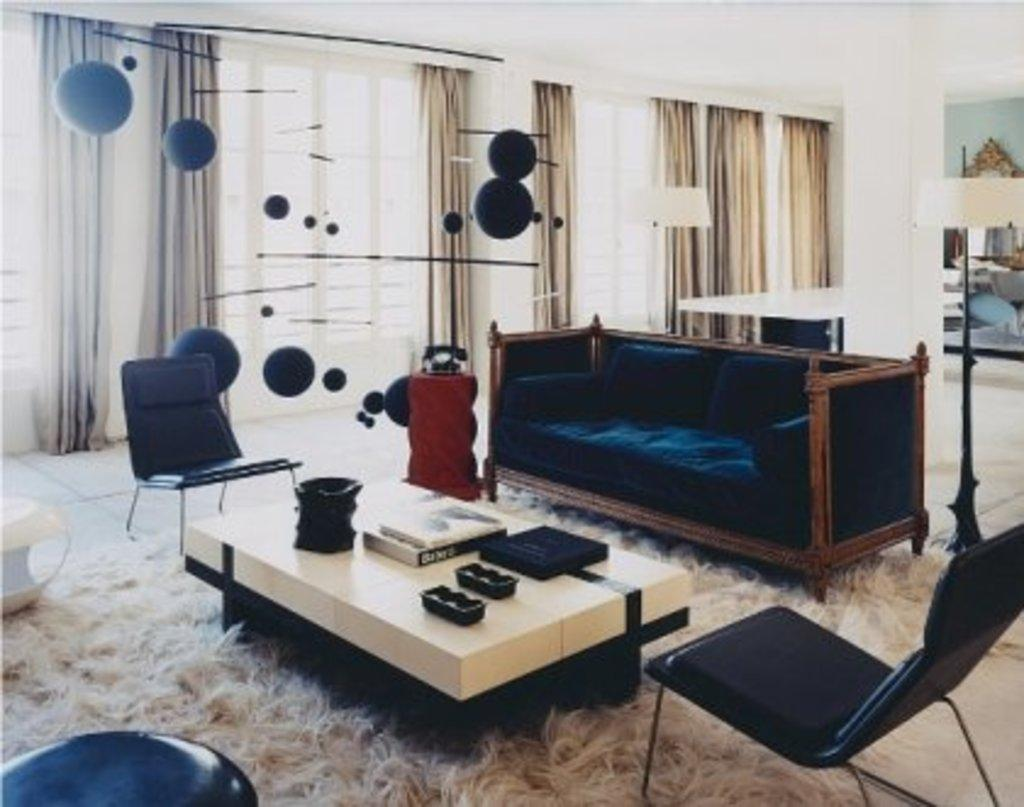What type of structure can be seen in the image? There is a wall in the image. What type of window treatment is present in the image? There are curtains in the image. What architectural feature is visible in the image? There is a window in the image. What type of furniture is present in the image? There are chairs in the image. What type of surface is visible in the image? There is a table in the image. What type of transport is visible in the image? There is no transport visible in the image. What type of agreement is being signed in the image? There is no agreement or signing activity present in the image. What type of nation is depicted in the image? There is no nation depicted in the image. 